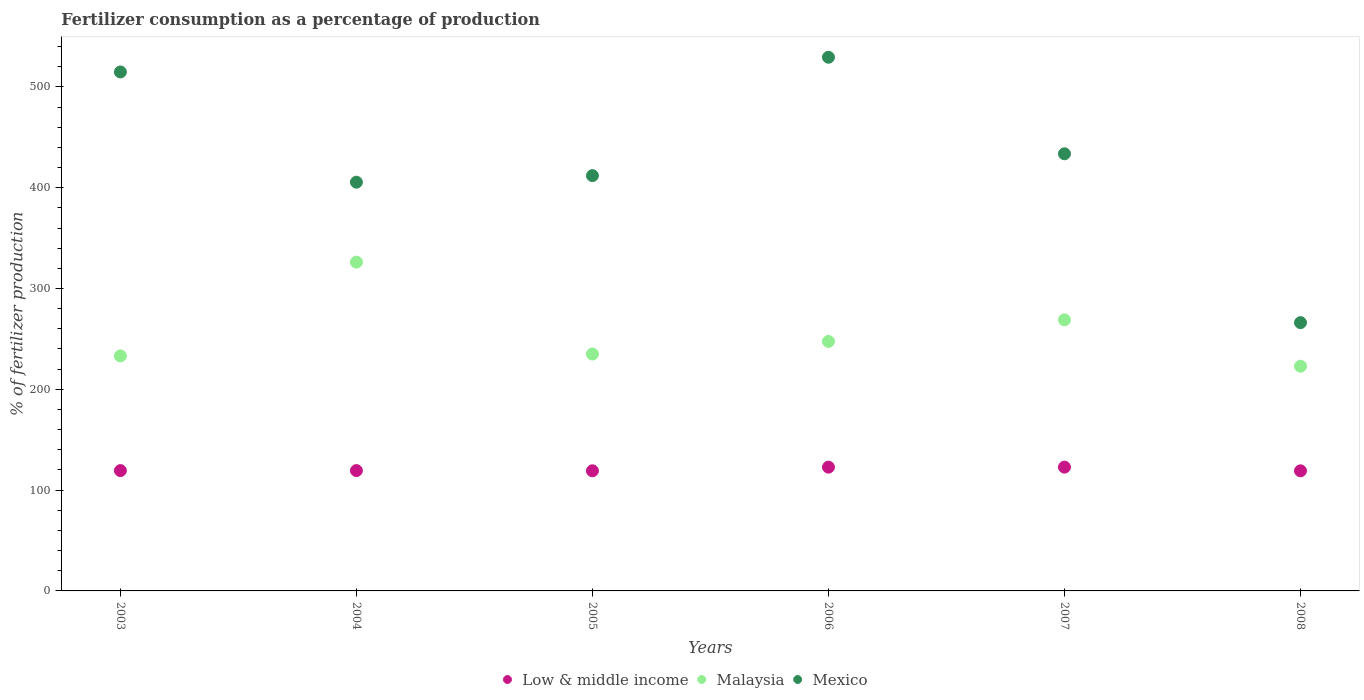How many different coloured dotlines are there?
Offer a very short reply. 3. What is the percentage of fertilizers consumed in Low & middle income in 2008?
Give a very brief answer. 119.13. Across all years, what is the maximum percentage of fertilizers consumed in Mexico?
Offer a very short reply. 529.39. Across all years, what is the minimum percentage of fertilizers consumed in Low & middle income?
Your response must be concise. 119.13. What is the total percentage of fertilizers consumed in Low & middle income in the graph?
Provide a succinct answer. 722.6. What is the difference between the percentage of fertilizers consumed in Low & middle income in 2005 and that in 2006?
Ensure brevity in your answer.  -3.64. What is the difference between the percentage of fertilizers consumed in Mexico in 2003 and the percentage of fertilizers consumed in Low & middle income in 2008?
Ensure brevity in your answer.  395.67. What is the average percentage of fertilizers consumed in Malaysia per year?
Provide a succinct answer. 255.6. In the year 2005, what is the difference between the percentage of fertilizers consumed in Low & middle income and percentage of fertilizers consumed in Malaysia?
Your answer should be compact. -115.85. In how many years, is the percentage of fertilizers consumed in Low & middle income greater than 480 %?
Your answer should be very brief. 0. What is the ratio of the percentage of fertilizers consumed in Mexico in 2006 to that in 2007?
Make the answer very short. 1.22. What is the difference between the highest and the second highest percentage of fertilizers consumed in Mexico?
Provide a short and direct response. 14.58. What is the difference between the highest and the lowest percentage of fertilizers consumed in Mexico?
Give a very brief answer. 263.27. In how many years, is the percentage of fertilizers consumed in Low & middle income greater than the average percentage of fertilizers consumed in Low & middle income taken over all years?
Your response must be concise. 2. Is it the case that in every year, the sum of the percentage of fertilizers consumed in Mexico and percentage of fertilizers consumed in Low & middle income  is greater than the percentage of fertilizers consumed in Malaysia?
Give a very brief answer. Yes. Does the percentage of fertilizers consumed in Malaysia monotonically increase over the years?
Provide a short and direct response. No. Does the graph contain any zero values?
Keep it short and to the point. No. Does the graph contain grids?
Your answer should be compact. No. What is the title of the graph?
Your response must be concise. Fertilizer consumption as a percentage of production. What is the label or title of the Y-axis?
Offer a terse response. % of fertilizer production. What is the % of fertilizer production of Low & middle income in 2003?
Your answer should be compact. 119.36. What is the % of fertilizer production in Malaysia in 2003?
Your answer should be compact. 233.12. What is the % of fertilizer production of Mexico in 2003?
Your answer should be compact. 514.81. What is the % of fertilizer production in Low & middle income in 2004?
Provide a short and direct response. 119.38. What is the % of fertilizer production in Malaysia in 2004?
Ensure brevity in your answer.  326.16. What is the % of fertilizer production in Mexico in 2004?
Give a very brief answer. 405.44. What is the % of fertilizer production of Low & middle income in 2005?
Offer a terse response. 119.15. What is the % of fertilizer production in Malaysia in 2005?
Give a very brief answer. 235. What is the % of fertilizer production of Mexico in 2005?
Provide a short and direct response. 411.97. What is the % of fertilizer production in Low & middle income in 2006?
Offer a very short reply. 122.79. What is the % of fertilizer production in Malaysia in 2006?
Offer a terse response. 247.51. What is the % of fertilizer production in Mexico in 2006?
Your answer should be compact. 529.39. What is the % of fertilizer production in Low & middle income in 2007?
Provide a short and direct response. 122.79. What is the % of fertilizer production of Malaysia in 2007?
Your answer should be very brief. 268.91. What is the % of fertilizer production of Mexico in 2007?
Your answer should be compact. 433.62. What is the % of fertilizer production of Low & middle income in 2008?
Provide a succinct answer. 119.13. What is the % of fertilizer production of Malaysia in 2008?
Make the answer very short. 222.9. What is the % of fertilizer production of Mexico in 2008?
Keep it short and to the point. 266.11. Across all years, what is the maximum % of fertilizer production of Low & middle income?
Ensure brevity in your answer.  122.79. Across all years, what is the maximum % of fertilizer production of Malaysia?
Give a very brief answer. 326.16. Across all years, what is the maximum % of fertilizer production in Mexico?
Your answer should be compact. 529.39. Across all years, what is the minimum % of fertilizer production of Low & middle income?
Ensure brevity in your answer.  119.13. Across all years, what is the minimum % of fertilizer production in Malaysia?
Provide a succinct answer. 222.9. Across all years, what is the minimum % of fertilizer production of Mexico?
Your response must be concise. 266.11. What is the total % of fertilizer production of Low & middle income in the graph?
Offer a terse response. 722.6. What is the total % of fertilizer production in Malaysia in the graph?
Your answer should be very brief. 1533.6. What is the total % of fertilizer production in Mexico in the graph?
Your response must be concise. 2561.33. What is the difference between the % of fertilizer production in Low & middle income in 2003 and that in 2004?
Your answer should be very brief. -0.02. What is the difference between the % of fertilizer production of Malaysia in 2003 and that in 2004?
Offer a very short reply. -93.04. What is the difference between the % of fertilizer production of Mexico in 2003 and that in 2004?
Provide a short and direct response. 109.37. What is the difference between the % of fertilizer production in Low & middle income in 2003 and that in 2005?
Your answer should be very brief. 0.2. What is the difference between the % of fertilizer production in Malaysia in 2003 and that in 2005?
Ensure brevity in your answer.  -1.88. What is the difference between the % of fertilizer production of Mexico in 2003 and that in 2005?
Provide a short and direct response. 102.84. What is the difference between the % of fertilizer production in Low & middle income in 2003 and that in 2006?
Keep it short and to the point. -3.43. What is the difference between the % of fertilizer production in Malaysia in 2003 and that in 2006?
Your answer should be very brief. -14.39. What is the difference between the % of fertilizer production in Mexico in 2003 and that in 2006?
Give a very brief answer. -14.58. What is the difference between the % of fertilizer production of Low & middle income in 2003 and that in 2007?
Offer a very short reply. -3.44. What is the difference between the % of fertilizer production in Malaysia in 2003 and that in 2007?
Keep it short and to the point. -35.79. What is the difference between the % of fertilizer production in Mexico in 2003 and that in 2007?
Offer a very short reply. 81.18. What is the difference between the % of fertilizer production in Low & middle income in 2003 and that in 2008?
Your answer should be very brief. 0.22. What is the difference between the % of fertilizer production in Malaysia in 2003 and that in 2008?
Offer a very short reply. 10.22. What is the difference between the % of fertilizer production in Mexico in 2003 and that in 2008?
Your answer should be very brief. 248.69. What is the difference between the % of fertilizer production in Low & middle income in 2004 and that in 2005?
Your answer should be compact. 0.23. What is the difference between the % of fertilizer production in Malaysia in 2004 and that in 2005?
Your response must be concise. 91.16. What is the difference between the % of fertilizer production in Mexico in 2004 and that in 2005?
Your response must be concise. -6.53. What is the difference between the % of fertilizer production of Low & middle income in 2004 and that in 2006?
Offer a terse response. -3.41. What is the difference between the % of fertilizer production of Malaysia in 2004 and that in 2006?
Offer a very short reply. 78.65. What is the difference between the % of fertilizer production of Mexico in 2004 and that in 2006?
Keep it short and to the point. -123.95. What is the difference between the % of fertilizer production in Low & middle income in 2004 and that in 2007?
Make the answer very short. -3.42. What is the difference between the % of fertilizer production of Malaysia in 2004 and that in 2007?
Your answer should be compact. 57.25. What is the difference between the % of fertilizer production of Mexico in 2004 and that in 2007?
Offer a terse response. -28.18. What is the difference between the % of fertilizer production in Low & middle income in 2004 and that in 2008?
Make the answer very short. 0.25. What is the difference between the % of fertilizer production in Malaysia in 2004 and that in 2008?
Offer a very short reply. 103.26. What is the difference between the % of fertilizer production in Mexico in 2004 and that in 2008?
Your response must be concise. 139.32. What is the difference between the % of fertilizer production of Low & middle income in 2005 and that in 2006?
Ensure brevity in your answer.  -3.64. What is the difference between the % of fertilizer production of Malaysia in 2005 and that in 2006?
Your answer should be compact. -12.51. What is the difference between the % of fertilizer production of Mexico in 2005 and that in 2006?
Your response must be concise. -117.42. What is the difference between the % of fertilizer production in Low & middle income in 2005 and that in 2007?
Ensure brevity in your answer.  -3.64. What is the difference between the % of fertilizer production of Malaysia in 2005 and that in 2007?
Give a very brief answer. -33.91. What is the difference between the % of fertilizer production in Mexico in 2005 and that in 2007?
Your response must be concise. -21.66. What is the difference between the % of fertilizer production in Low & middle income in 2005 and that in 2008?
Provide a short and direct response. 0.02. What is the difference between the % of fertilizer production in Malaysia in 2005 and that in 2008?
Your answer should be compact. 12.1. What is the difference between the % of fertilizer production of Mexico in 2005 and that in 2008?
Provide a short and direct response. 145.85. What is the difference between the % of fertilizer production in Low & middle income in 2006 and that in 2007?
Offer a very short reply. -0.01. What is the difference between the % of fertilizer production of Malaysia in 2006 and that in 2007?
Your answer should be very brief. -21.4. What is the difference between the % of fertilizer production of Mexico in 2006 and that in 2007?
Give a very brief answer. 95.76. What is the difference between the % of fertilizer production in Low & middle income in 2006 and that in 2008?
Give a very brief answer. 3.66. What is the difference between the % of fertilizer production of Malaysia in 2006 and that in 2008?
Make the answer very short. 24.6. What is the difference between the % of fertilizer production in Mexico in 2006 and that in 2008?
Your response must be concise. 263.27. What is the difference between the % of fertilizer production of Low & middle income in 2007 and that in 2008?
Make the answer very short. 3.66. What is the difference between the % of fertilizer production of Malaysia in 2007 and that in 2008?
Your answer should be very brief. 46.01. What is the difference between the % of fertilizer production of Mexico in 2007 and that in 2008?
Provide a short and direct response. 167.51. What is the difference between the % of fertilizer production in Low & middle income in 2003 and the % of fertilizer production in Malaysia in 2004?
Offer a very short reply. -206.8. What is the difference between the % of fertilizer production in Low & middle income in 2003 and the % of fertilizer production in Mexico in 2004?
Provide a short and direct response. -286.08. What is the difference between the % of fertilizer production in Malaysia in 2003 and the % of fertilizer production in Mexico in 2004?
Keep it short and to the point. -172.32. What is the difference between the % of fertilizer production in Low & middle income in 2003 and the % of fertilizer production in Malaysia in 2005?
Make the answer very short. -115.64. What is the difference between the % of fertilizer production of Low & middle income in 2003 and the % of fertilizer production of Mexico in 2005?
Your answer should be very brief. -292.61. What is the difference between the % of fertilizer production of Malaysia in 2003 and the % of fertilizer production of Mexico in 2005?
Ensure brevity in your answer.  -178.85. What is the difference between the % of fertilizer production in Low & middle income in 2003 and the % of fertilizer production in Malaysia in 2006?
Offer a terse response. -128.15. What is the difference between the % of fertilizer production in Low & middle income in 2003 and the % of fertilizer production in Mexico in 2006?
Provide a short and direct response. -410.03. What is the difference between the % of fertilizer production of Malaysia in 2003 and the % of fertilizer production of Mexico in 2006?
Offer a terse response. -296.27. What is the difference between the % of fertilizer production in Low & middle income in 2003 and the % of fertilizer production in Malaysia in 2007?
Offer a terse response. -149.55. What is the difference between the % of fertilizer production in Low & middle income in 2003 and the % of fertilizer production in Mexico in 2007?
Your response must be concise. -314.26. What is the difference between the % of fertilizer production of Malaysia in 2003 and the % of fertilizer production of Mexico in 2007?
Ensure brevity in your answer.  -200.5. What is the difference between the % of fertilizer production in Low & middle income in 2003 and the % of fertilizer production in Malaysia in 2008?
Ensure brevity in your answer.  -103.55. What is the difference between the % of fertilizer production of Low & middle income in 2003 and the % of fertilizer production of Mexico in 2008?
Offer a very short reply. -146.76. What is the difference between the % of fertilizer production in Malaysia in 2003 and the % of fertilizer production in Mexico in 2008?
Make the answer very short. -32.99. What is the difference between the % of fertilizer production in Low & middle income in 2004 and the % of fertilizer production in Malaysia in 2005?
Your response must be concise. -115.62. What is the difference between the % of fertilizer production in Low & middle income in 2004 and the % of fertilizer production in Mexico in 2005?
Your response must be concise. -292.59. What is the difference between the % of fertilizer production in Malaysia in 2004 and the % of fertilizer production in Mexico in 2005?
Make the answer very short. -85.81. What is the difference between the % of fertilizer production of Low & middle income in 2004 and the % of fertilizer production of Malaysia in 2006?
Ensure brevity in your answer.  -128.13. What is the difference between the % of fertilizer production of Low & middle income in 2004 and the % of fertilizer production of Mexico in 2006?
Provide a short and direct response. -410.01. What is the difference between the % of fertilizer production of Malaysia in 2004 and the % of fertilizer production of Mexico in 2006?
Make the answer very short. -203.23. What is the difference between the % of fertilizer production of Low & middle income in 2004 and the % of fertilizer production of Malaysia in 2007?
Offer a very short reply. -149.53. What is the difference between the % of fertilizer production of Low & middle income in 2004 and the % of fertilizer production of Mexico in 2007?
Offer a very short reply. -314.24. What is the difference between the % of fertilizer production in Malaysia in 2004 and the % of fertilizer production in Mexico in 2007?
Offer a very short reply. -107.46. What is the difference between the % of fertilizer production of Low & middle income in 2004 and the % of fertilizer production of Malaysia in 2008?
Provide a succinct answer. -103.52. What is the difference between the % of fertilizer production in Low & middle income in 2004 and the % of fertilizer production in Mexico in 2008?
Your answer should be compact. -146.74. What is the difference between the % of fertilizer production of Malaysia in 2004 and the % of fertilizer production of Mexico in 2008?
Give a very brief answer. 60.04. What is the difference between the % of fertilizer production in Low & middle income in 2005 and the % of fertilizer production in Malaysia in 2006?
Give a very brief answer. -128.36. What is the difference between the % of fertilizer production of Low & middle income in 2005 and the % of fertilizer production of Mexico in 2006?
Keep it short and to the point. -410.23. What is the difference between the % of fertilizer production in Malaysia in 2005 and the % of fertilizer production in Mexico in 2006?
Make the answer very short. -294.39. What is the difference between the % of fertilizer production in Low & middle income in 2005 and the % of fertilizer production in Malaysia in 2007?
Offer a terse response. -149.76. What is the difference between the % of fertilizer production in Low & middle income in 2005 and the % of fertilizer production in Mexico in 2007?
Make the answer very short. -314.47. What is the difference between the % of fertilizer production of Malaysia in 2005 and the % of fertilizer production of Mexico in 2007?
Provide a succinct answer. -198.62. What is the difference between the % of fertilizer production of Low & middle income in 2005 and the % of fertilizer production of Malaysia in 2008?
Make the answer very short. -103.75. What is the difference between the % of fertilizer production in Low & middle income in 2005 and the % of fertilizer production in Mexico in 2008?
Provide a succinct answer. -146.96. What is the difference between the % of fertilizer production in Malaysia in 2005 and the % of fertilizer production in Mexico in 2008?
Provide a short and direct response. -31.11. What is the difference between the % of fertilizer production of Low & middle income in 2006 and the % of fertilizer production of Malaysia in 2007?
Offer a terse response. -146.12. What is the difference between the % of fertilizer production in Low & middle income in 2006 and the % of fertilizer production in Mexico in 2007?
Provide a short and direct response. -310.83. What is the difference between the % of fertilizer production in Malaysia in 2006 and the % of fertilizer production in Mexico in 2007?
Your response must be concise. -186.11. What is the difference between the % of fertilizer production of Low & middle income in 2006 and the % of fertilizer production of Malaysia in 2008?
Provide a short and direct response. -100.11. What is the difference between the % of fertilizer production of Low & middle income in 2006 and the % of fertilizer production of Mexico in 2008?
Offer a very short reply. -143.33. What is the difference between the % of fertilizer production of Malaysia in 2006 and the % of fertilizer production of Mexico in 2008?
Keep it short and to the point. -18.61. What is the difference between the % of fertilizer production of Low & middle income in 2007 and the % of fertilizer production of Malaysia in 2008?
Make the answer very short. -100.11. What is the difference between the % of fertilizer production of Low & middle income in 2007 and the % of fertilizer production of Mexico in 2008?
Give a very brief answer. -143.32. What is the difference between the % of fertilizer production in Malaysia in 2007 and the % of fertilizer production in Mexico in 2008?
Give a very brief answer. 2.79. What is the average % of fertilizer production of Low & middle income per year?
Ensure brevity in your answer.  120.43. What is the average % of fertilizer production of Malaysia per year?
Provide a succinct answer. 255.6. What is the average % of fertilizer production of Mexico per year?
Keep it short and to the point. 426.89. In the year 2003, what is the difference between the % of fertilizer production in Low & middle income and % of fertilizer production in Malaysia?
Provide a short and direct response. -113.76. In the year 2003, what is the difference between the % of fertilizer production in Low & middle income and % of fertilizer production in Mexico?
Ensure brevity in your answer.  -395.45. In the year 2003, what is the difference between the % of fertilizer production in Malaysia and % of fertilizer production in Mexico?
Your response must be concise. -281.69. In the year 2004, what is the difference between the % of fertilizer production of Low & middle income and % of fertilizer production of Malaysia?
Keep it short and to the point. -206.78. In the year 2004, what is the difference between the % of fertilizer production in Low & middle income and % of fertilizer production in Mexico?
Your answer should be very brief. -286.06. In the year 2004, what is the difference between the % of fertilizer production of Malaysia and % of fertilizer production of Mexico?
Keep it short and to the point. -79.28. In the year 2005, what is the difference between the % of fertilizer production in Low & middle income and % of fertilizer production in Malaysia?
Ensure brevity in your answer.  -115.85. In the year 2005, what is the difference between the % of fertilizer production in Low & middle income and % of fertilizer production in Mexico?
Provide a short and direct response. -292.81. In the year 2005, what is the difference between the % of fertilizer production in Malaysia and % of fertilizer production in Mexico?
Give a very brief answer. -176.97. In the year 2006, what is the difference between the % of fertilizer production in Low & middle income and % of fertilizer production in Malaysia?
Offer a terse response. -124.72. In the year 2006, what is the difference between the % of fertilizer production in Low & middle income and % of fertilizer production in Mexico?
Your answer should be very brief. -406.6. In the year 2006, what is the difference between the % of fertilizer production of Malaysia and % of fertilizer production of Mexico?
Your answer should be very brief. -281.88. In the year 2007, what is the difference between the % of fertilizer production in Low & middle income and % of fertilizer production in Malaysia?
Provide a short and direct response. -146.12. In the year 2007, what is the difference between the % of fertilizer production in Low & middle income and % of fertilizer production in Mexico?
Keep it short and to the point. -310.83. In the year 2007, what is the difference between the % of fertilizer production in Malaysia and % of fertilizer production in Mexico?
Make the answer very short. -164.71. In the year 2008, what is the difference between the % of fertilizer production of Low & middle income and % of fertilizer production of Malaysia?
Offer a terse response. -103.77. In the year 2008, what is the difference between the % of fertilizer production in Low & middle income and % of fertilizer production in Mexico?
Your answer should be very brief. -146.98. In the year 2008, what is the difference between the % of fertilizer production in Malaysia and % of fertilizer production in Mexico?
Your answer should be compact. -43.21. What is the ratio of the % of fertilizer production in Low & middle income in 2003 to that in 2004?
Provide a succinct answer. 1. What is the ratio of the % of fertilizer production in Malaysia in 2003 to that in 2004?
Give a very brief answer. 0.71. What is the ratio of the % of fertilizer production of Mexico in 2003 to that in 2004?
Your answer should be very brief. 1.27. What is the ratio of the % of fertilizer production in Mexico in 2003 to that in 2005?
Your answer should be very brief. 1.25. What is the ratio of the % of fertilizer production of Low & middle income in 2003 to that in 2006?
Offer a terse response. 0.97. What is the ratio of the % of fertilizer production in Malaysia in 2003 to that in 2006?
Give a very brief answer. 0.94. What is the ratio of the % of fertilizer production in Mexico in 2003 to that in 2006?
Ensure brevity in your answer.  0.97. What is the ratio of the % of fertilizer production of Low & middle income in 2003 to that in 2007?
Your answer should be compact. 0.97. What is the ratio of the % of fertilizer production in Malaysia in 2003 to that in 2007?
Provide a succinct answer. 0.87. What is the ratio of the % of fertilizer production in Mexico in 2003 to that in 2007?
Offer a terse response. 1.19. What is the ratio of the % of fertilizer production in Malaysia in 2003 to that in 2008?
Your response must be concise. 1.05. What is the ratio of the % of fertilizer production of Mexico in 2003 to that in 2008?
Ensure brevity in your answer.  1.93. What is the ratio of the % of fertilizer production of Low & middle income in 2004 to that in 2005?
Give a very brief answer. 1. What is the ratio of the % of fertilizer production in Malaysia in 2004 to that in 2005?
Keep it short and to the point. 1.39. What is the ratio of the % of fertilizer production of Mexico in 2004 to that in 2005?
Offer a terse response. 0.98. What is the ratio of the % of fertilizer production of Low & middle income in 2004 to that in 2006?
Provide a succinct answer. 0.97. What is the ratio of the % of fertilizer production of Malaysia in 2004 to that in 2006?
Ensure brevity in your answer.  1.32. What is the ratio of the % of fertilizer production of Mexico in 2004 to that in 2006?
Provide a short and direct response. 0.77. What is the ratio of the % of fertilizer production in Low & middle income in 2004 to that in 2007?
Offer a terse response. 0.97. What is the ratio of the % of fertilizer production in Malaysia in 2004 to that in 2007?
Give a very brief answer. 1.21. What is the ratio of the % of fertilizer production in Mexico in 2004 to that in 2007?
Your answer should be compact. 0.94. What is the ratio of the % of fertilizer production of Low & middle income in 2004 to that in 2008?
Offer a very short reply. 1. What is the ratio of the % of fertilizer production in Malaysia in 2004 to that in 2008?
Give a very brief answer. 1.46. What is the ratio of the % of fertilizer production in Mexico in 2004 to that in 2008?
Your answer should be compact. 1.52. What is the ratio of the % of fertilizer production of Low & middle income in 2005 to that in 2006?
Your answer should be compact. 0.97. What is the ratio of the % of fertilizer production in Malaysia in 2005 to that in 2006?
Ensure brevity in your answer.  0.95. What is the ratio of the % of fertilizer production in Mexico in 2005 to that in 2006?
Keep it short and to the point. 0.78. What is the ratio of the % of fertilizer production in Low & middle income in 2005 to that in 2007?
Offer a terse response. 0.97. What is the ratio of the % of fertilizer production of Malaysia in 2005 to that in 2007?
Make the answer very short. 0.87. What is the ratio of the % of fertilizer production in Mexico in 2005 to that in 2007?
Your answer should be compact. 0.95. What is the ratio of the % of fertilizer production in Low & middle income in 2005 to that in 2008?
Your answer should be compact. 1. What is the ratio of the % of fertilizer production in Malaysia in 2005 to that in 2008?
Provide a short and direct response. 1.05. What is the ratio of the % of fertilizer production in Mexico in 2005 to that in 2008?
Offer a very short reply. 1.55. What is the ratio of the % of fertilizer production in Low & middle income in 2006 to that in 2007?
Keep it short and to the point. 1. What is the ratio of the % of fertilizer production in Malaysia in 2006 to that in 2007?
Ensure brevity in your answer.  0.92. What is the ratio of the % of fertilizer production of Mexico in 2006 to that in 2007?
Give a very brief answer. 1.22. What is the ratio of the % of fertilizer production in Low & middle income in 2006 to that in 2008?
Make the answer very short. 1.03. What is the ratio of the % of fertilizer production in Malaysia in 2006 to that in 2008?
Ensure brevity in your answer.  1.11. What is the ratio of the % of fertilizer production in Mexico in 2006 to that in 2008?
Provide a short and direct response. 1.99. What is the ratio of the % of fertilizer production of Low & middle income in 2007 to that in 2008?
Ensure brevity in your answer.  1.03. What is the ratio of the % of fertilizer production of Malaysia in 2007 to that in 2008?
Give a very brief answer. 1.21. What is the ratio of the % of fertilizer production in Mexico in 2007 to that in 2008?
Make the answer very short. 1.63. What is the difference between the highest and the second highest % of fertilizer production of Low & middle income?
Your answer should be compact. 0.01. What is the difference between the highest and the second highest % of fertilizer production of Malaysia?
Ensure brevity in your answer.  57.25. What is the difference between the highest and the second highest % of fertilizer production of Mexico?
Your answer should be compact. 14.58. What is the difference between the highest and the lowest % of fertilizer production in Low & middle income?
Give a very brief answer. 3.66. What is the difference between the highest and the lowest % of fertilizer production in Malaysia?
Your answer should be compact. 103.26. What is the difference between the highest and the lowest % of fertilizer production of Mexico?
Your answer should be compact. 263.27. 